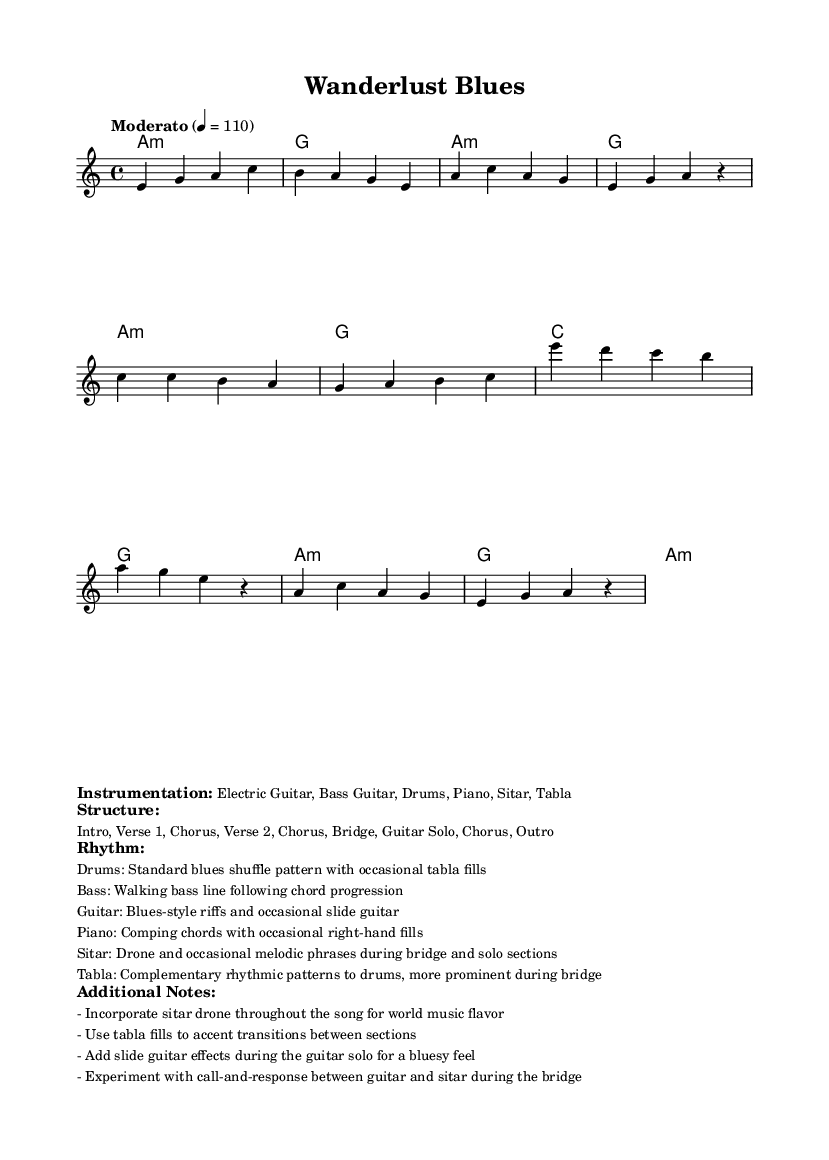What is the key signature of this music? The key signature is A minor, which has no sharps or flats.
Answer: A minor What is the time signature of this music? The time signature is 4/4, meaning there are four beats in each measure.
Answer: 4/4 What is the tempo marking of this piece? The tempo marking is "Moderato," which indicates a moderate speed for the music, set at 110 beats per minute.
Answer: Moderato What instruments are included in the instrumentation? The listed instruments are Electric Guitar, Bass Guitar, Drums, Piano, Sitar, and Tabla, indicating a fusion of various styles.
Answer: Electric Guitar, Bass Guitar, Drums, Piano, Sitar, Tabla How many sections are in the structure of the music? The structure includes Intro, Verse 1, Chorus, Verse 2, Chorus, Bridge, Guitar Solo, Chorus, and Outro, totaling nine sections.
Answer: Nine sections Which rhythmic pattern is used by the drums? The drums employ a standard blues shuffle pattern, with tabla fills occasionally added for variation.
Answer: Standard blues shuffle pattern What element of world music is incorporated during the bridge and solo sections? The sitar is used for the drone and melodic phrases during both the bridge and solo sections, adding a unique world music flavor.
Answer: Sitar drone 